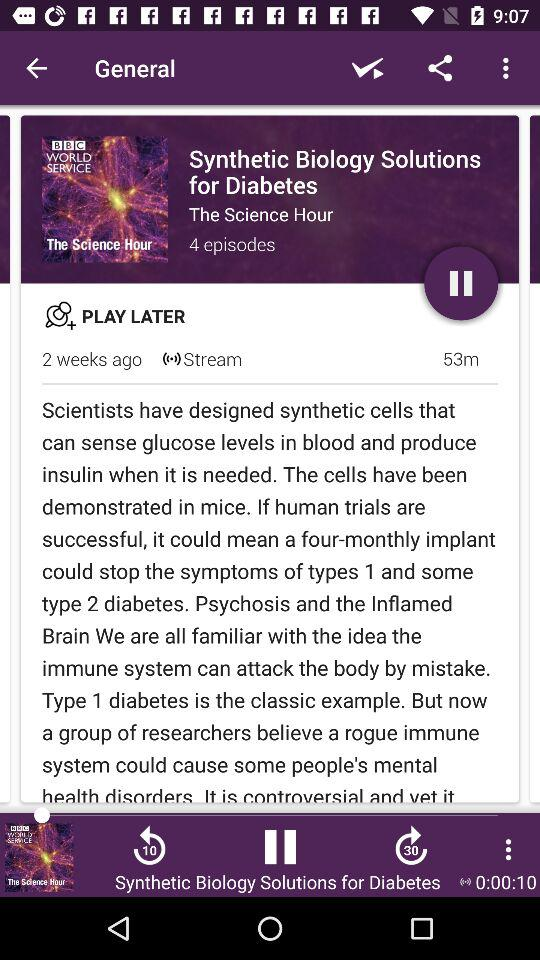What is the duration of the episode? The duration of the episode is 53 minutes. 